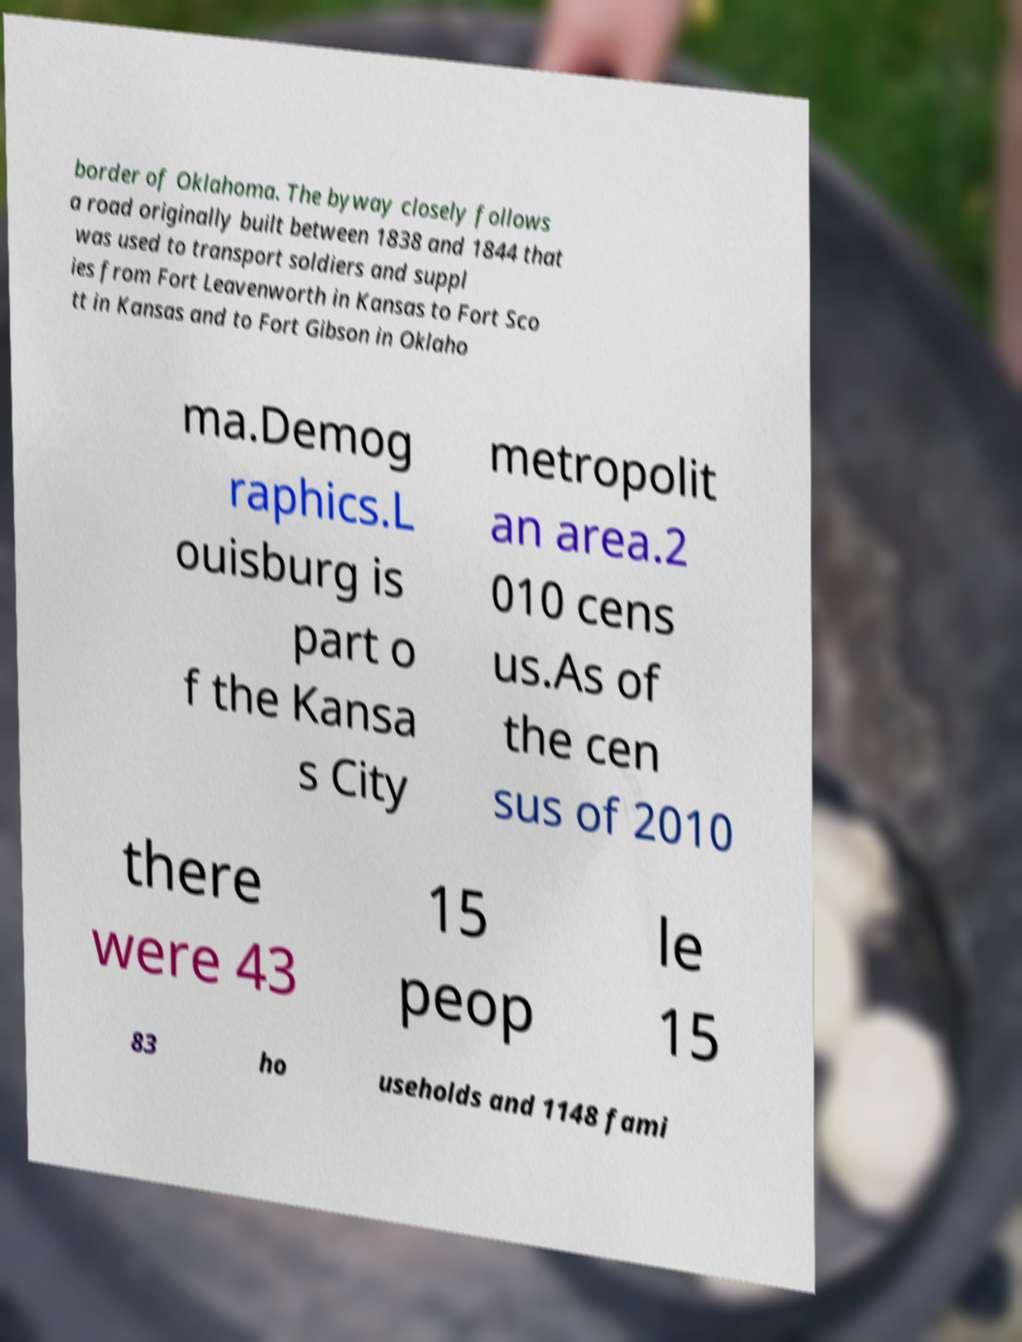Could you extract and type out the text from this image? border of Oklahoma. The byway closely follows a road originally built between 1838 and 1844 that was used to transport soldiers and suppl ies from Fort Leavenworth in Kansas to Fort Sco tt in Kansas and to Fort Gibson in Oklaho ma.Demog raphics.L ouisburg is part o f the Kansa s City metropolit an area.2 010 cens us.As of the cen sus of 2010 there were 43 15 peop le 15 83 ho useholds and 1148 fami 